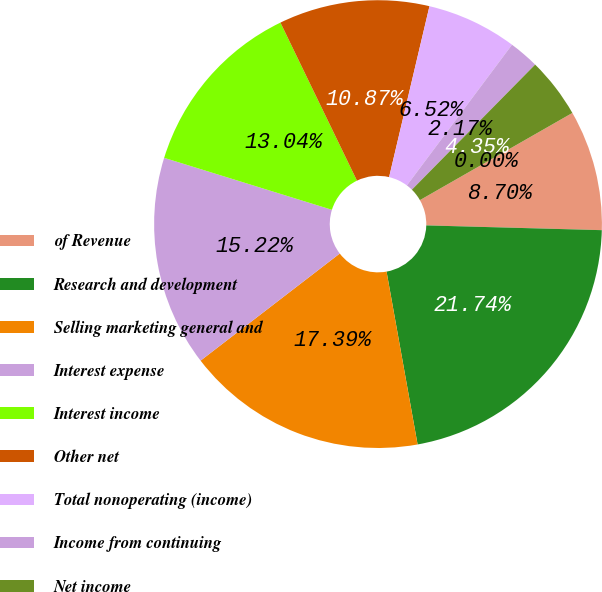<chart> <loc_0><loc_0><loc_500><loc_500><pie_chart><fcel>of Revenue<fcel>Research and development<fcel>Selling marketing general and<fcel>Interest expense<fcel>Interest income<fcel>Other net<fcel>Total nonoperating (income)<fcel>Income from continuing<fcel>Net income<fcel>Dividends declared per share<nl><fcel>8.7%<fcel>21.74%<fcel>17.39%<fcel>15.22%<fcel>13.04%<fcel>10.87%<fcel>6.52%<fcel>2.17%<fcel>4.35%<fcel>0.0%<nl></chart> 